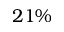Convert formula to latex. <formula><loc_0><loc_0><loc_500><loc_500>2 1 \%</formula> 